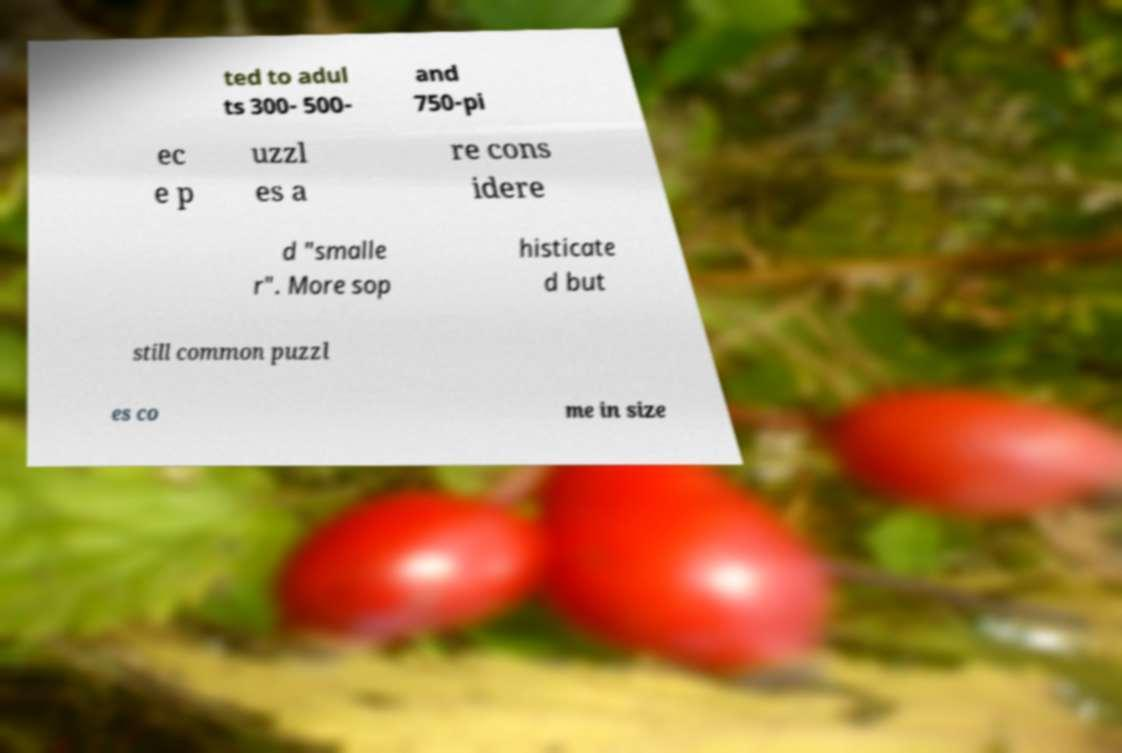Could you assist in decoding the text presented in this image and type it out clearly? ted to adul ts 300- 500- and 750-pi ec e p uzzl es a re cons idere d "smalle r". More sop histicate d but still common puzzl es co me in size 